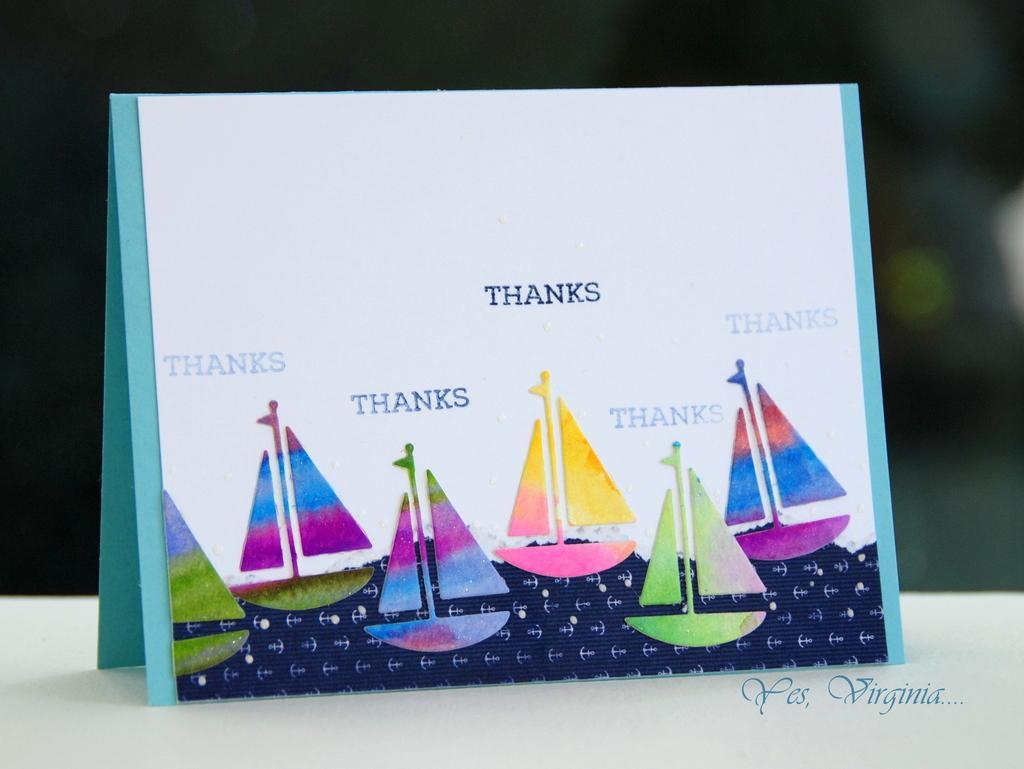How would you summarize this image in a sentence or two? This image consists of cards. On that card there is thanks written on it. There are pictures of boats on that card. 